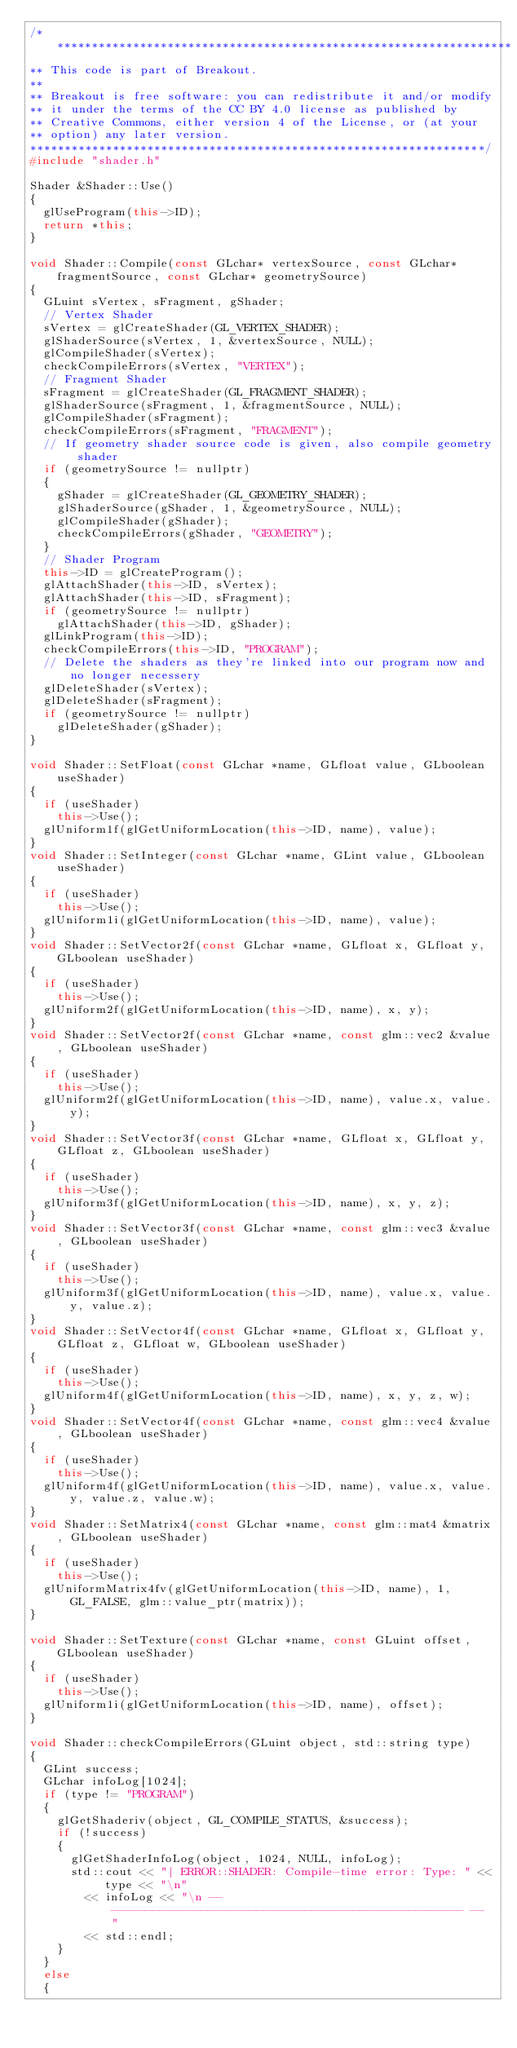Convert code to text. <code><loc_0><loc_0><loc_500><loc_500><_C++_>/*******************************************************************
** This code is part of Breakout.
**
** Breakout is free software: you can redistribute it and/or modify
** it under the terms of the CC BY 4.0 license as published by
** Creative Commons, either version 4 of the License, or (at your
** option) any later version.
******************************************************************/
#include "shader.h"

Shader &Shader::Use()
{
	glUseProgram(this->ID);
	return *this;
}

void Shader::Compile(const GLchar* vertexSource, const GLchar* fragmentSource, const GLchar* geometrySource)
{
	GLuint sVertex, sFragment, gShader;
	// Vertex Shader
	sVertex = glCreateShader(GL_VERTEX_SHADER);
	glShaderSource(sVertex, 1, &vertexSource, NULL);
	glCompileShader(sVertex);
	checkCompileErrors(sVertex, "VERTEX");
	// Fragment Shader
	sFragment = glCreateShader(GL_FRAGMENT_SHADER);
	glShaderSource(sFragment, 1, &fragmentSource, NULL);
	glCompileShader(sFragment);
	checkCompileErrors(sFragment, "FRAGMENT");
	// If geometry shader source code is given, also compile geometry shader
	if (geometrySource != nullptr)
	{
		gShader = glCreateShader(GL_GEOMETRY_SHADER);
		glShaderSource(gShader, 1, &geometrySource, NULL);
		glCompileShader(gShader);
		checkCompileErrors(gShader, "GEOMETRY");
	}
	// Shader Program
	this->ID = glCreateProgram();
	glAttachShader(this->ID, sVertex);
	glAttachShader(this->ID, sFragment);
	if (geometrySource != nullptr)
		glAttachShader(this->ID, gShader);
	glLinkProgram(this->ID);
	checkCompileErrors(this->ID, "PROGRAM");
	// Delete the shaders as they're linked into our program now and no longer necessery
	glDeleteShader(sVertex);
	glDeleteShader(sFragment);
	if (geometrySource != nullptr)
		glDeleteShader(gShader);
}

void Shader::SetFloat(const GLchar *name, GLfloat value, GLboolean useShader)
{
	if (useShader)
		this->Use();
	glUniform1f(glGetUniformLocation(this->ID, name), value);
}
void Shader::SetInteger(const GLchar *name, GLint value, GLboolean useShader)
{
	if (useShader)
		this->Use();
	glUniform1i(glGetUniformLocation(this->ID, name), value);
}
void Shader::SetVector2f(const GLchar *name, GLfloat x, GLfloat y, GLboolean useShader)
{
	if (useShader)
		this->Use();
	glUniform2f(glGetUniformLocation(this->ID, name), x, y);
}
void Shader::SetVector2f(const GLchar *name, const glm::vec2 &value, GLboolean useShader)
{
	if (useShader)
		this->Use();
	glUniform2f(glGetUniformLocation(this->ID, name), value.x, value.y);
}
void Shader::SetVector3f(const GLchar *name, GLfloat x, GLfloat y, GLfloat z, GLboolean useShader)
{
	if (useShader)
		this->Use();
	glUniform3f(glGetUniformLocation(this->ID, name), x, y, z);
}
void Shader::SetVector3f(const GLchar *name, const glm::vec3 &value, GLboolean useShader)
{
	if (useShader)
		this->Use();
	glUniform3f(glGetUniformLocation(this->ID, name), value.x, value.y, value.z);
}
void Shader::SetVector4f(const GLchar *name, GLfloat x, GLfloat y, GLfloat z, GLfloat w, GLboolean useShader)
{
	if (useShader)
		this->Use();
	glUniform4f(glGetUniformLocation(this->ID, name), x, y, z, w);
}
void Shader::SetVector4f(const GLchar *name, const glm::vec4 &value, GLboolean useShader)
{
	if (useShader)
		this->Use();
	glUniform4f(glGetUniformLocation(this->ID, name), value.x, value.y, value.z, value.w);
}
void Shader::SetMatrix4(const GLchar *name, const glm::mat4 &matrix, GLboolean useShader)
{
	if (useShader)
		this->Use();
	glUniformMatrix4fv(glGetUniformLocation(this->ID, name), 1, GL_FALSE, glm::value_ptr(matrix));
}

void Shader::SetTexture(const GLchar *name, const GLuint offset, GLboolean useShader)
{
	if (useShader)
		this->Use();
	glUniform1i(glGetUniformLocation(this->ID, name), offset);
}

void Shader::checkCompileErrors(GLuint object, std::string type)
{
	GLint success;
	GLchar infoLog[1024];
	if (type != "PROGRAM")
	{
		glGetShaderiv(object, GL_COMPILE_STATUS, &success);
		if (!success)
		{
			glGetShaderInfoLog(object, 1024, NULL, infoLog);
			std::cout << "| ERROR::SHADER: Compile-time error: Type: " << type << "\n"
				<< infoLog << "\n -- --------------------------------------------------- -- "
				<< std::endl;
		}
	}
	else
	{</code> 